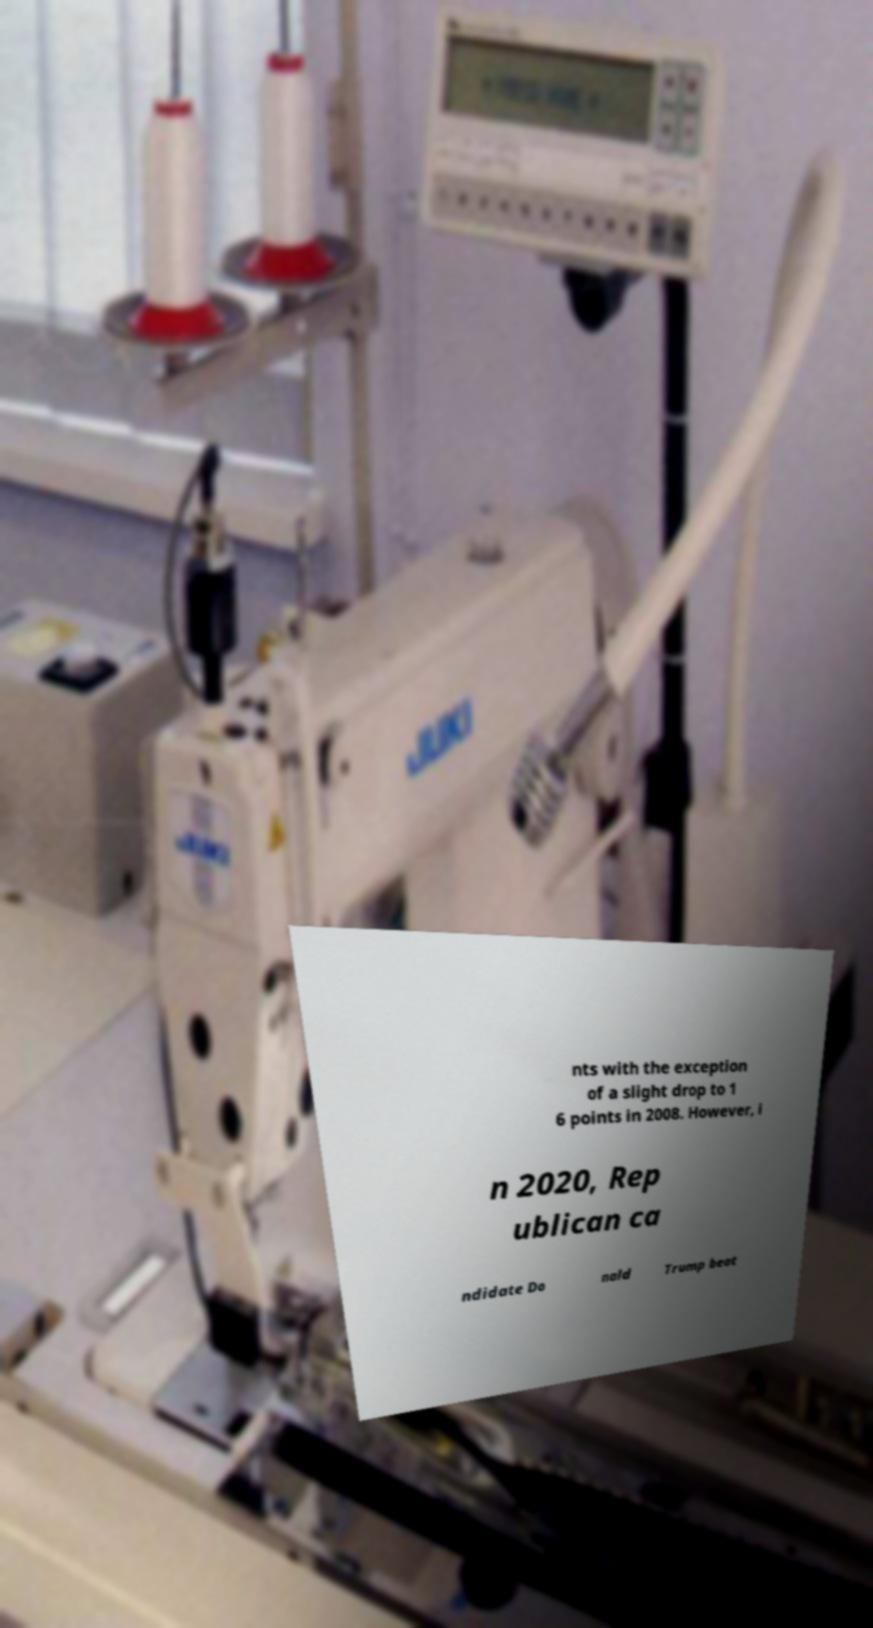Please identify and transcribe the text found in this image. nts with the exception of a slight drop to 1 6 points in 2008. However, i n 2020, Rep ublican ca ndidate Do nald Trump beat 